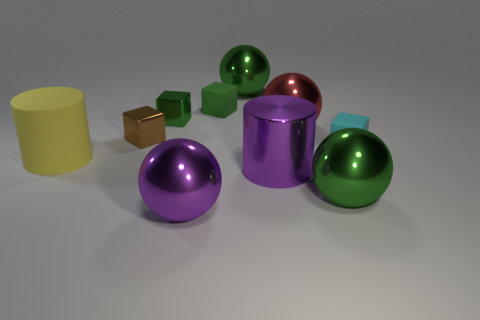Is the material of the small cyan block the same as the purple cylinder? Based on the image provided, it appears that the small cyan block and the purple cylinder differ in material properties. The cyan block has a more matte finish, indicative of a solid plastic or painted wood, while the purple cylinder exhibits a reflective surface, suggesting a material like polished metal or a high-gloss plastic. 